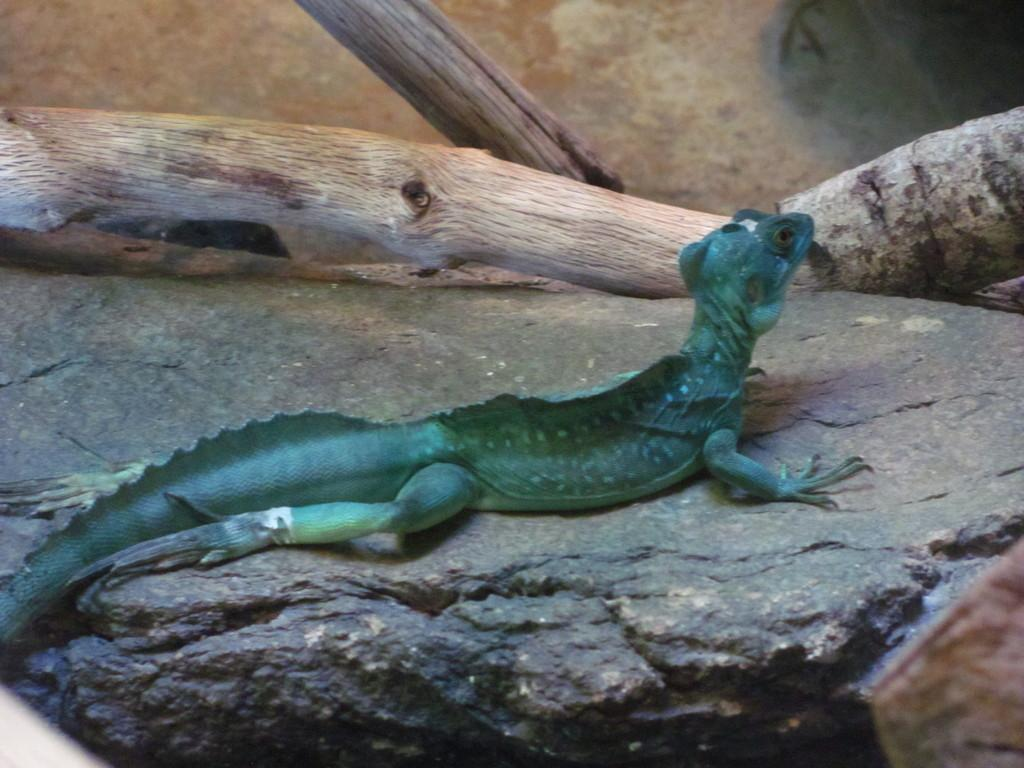What type of animal is in the image? There is a reptile in the image. Where is the reptile located? The reptile is on a rock. What can be seen in the background of the image? There is wood visible in the background of the image. How many spoons are in the image? There are no spoons present in the image. What type of bird is in the flock in the image? There is no flock or bird present in the image; it features a reptile on a rock. 